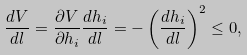Convert formula to latex. <formula><loc_0><loc_0><loc_500><loc_500>\frac { d V } { d l } = \frac { \partial V } { \partial h _ { i } } \frac { d h _ { i } } { d l } = - \left ( \frac { d h _ { i } } { d l } \right ) ^ { 2 } \leq 0 ,</formula> 